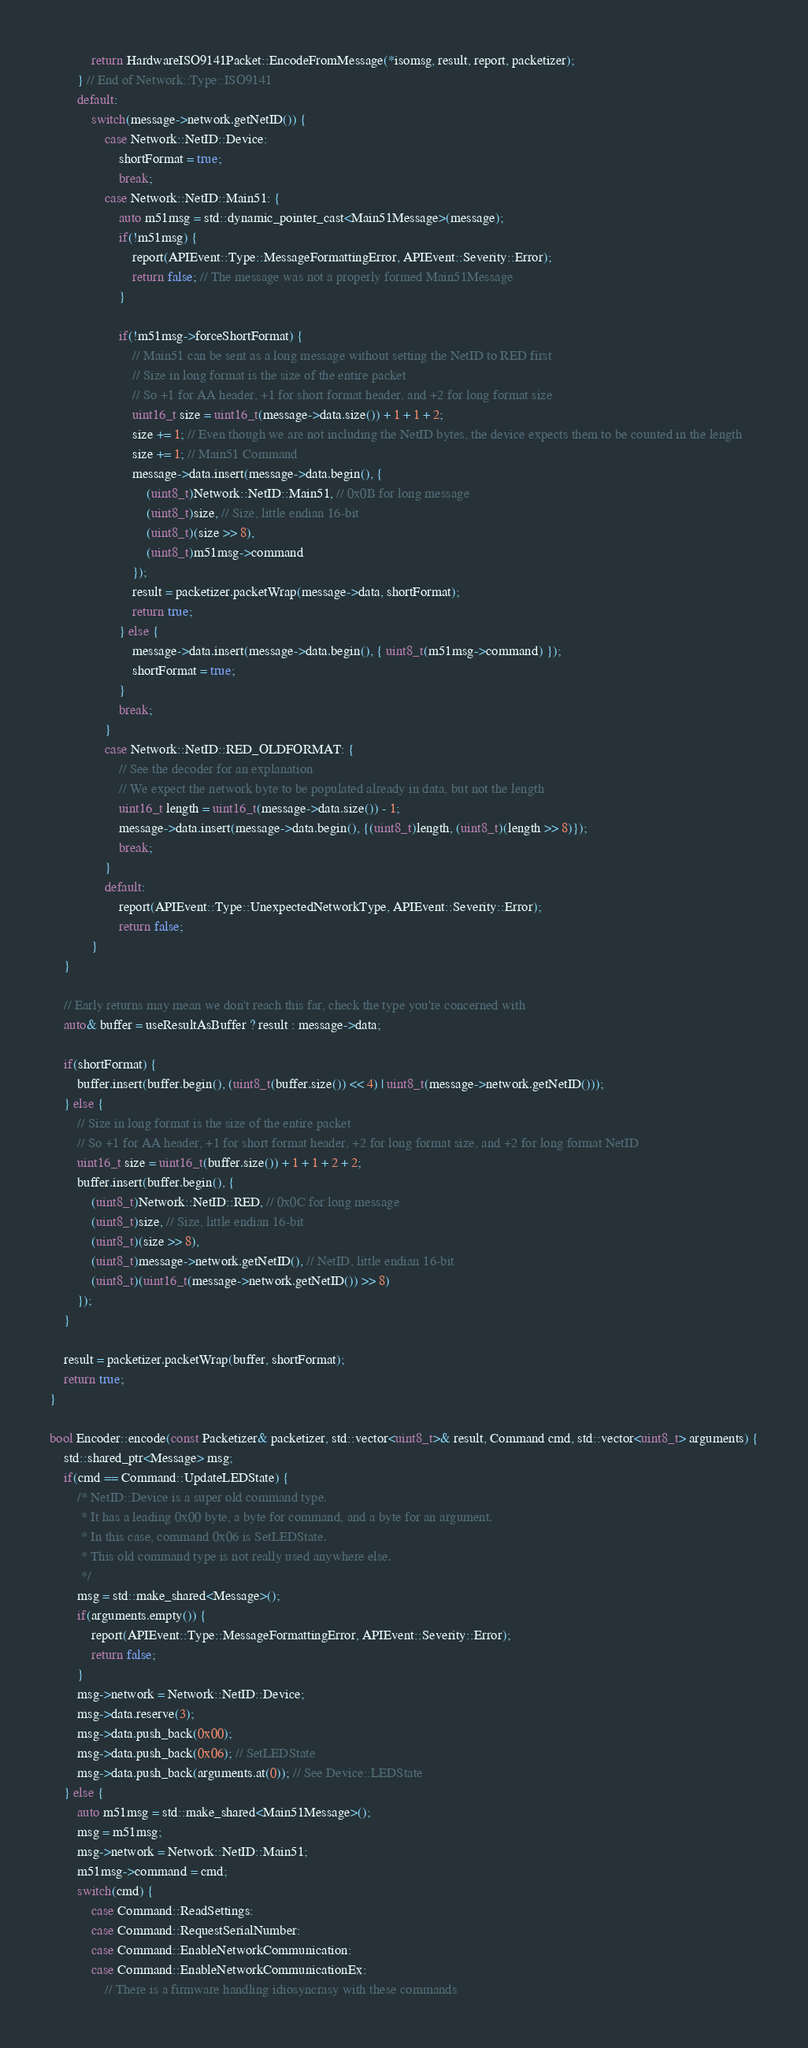<code> <loc_0><loc_0><loc_500><loc_500><_C++_>			return HardwareISO9141Packet::EncodeFromMessage(*isomsg, result, report, packetizer);
		} // End of Network::Type::ISO9141
		default:
			switch(message->network.getNetID()) {
				case Network::NetID::Device:
					shortFormat = true;
					break;
				case Network::NetID::Main51: {
					auto m51msg = std::dynamic_pointer_cast<Main51Message>(message);
					if(!m51msg) {
						report(APIEvent::Type::MessageFormattingError, APIEvent::Severity::Error);
						return false; // The message was not a properly formed Main51Message
					}

					if(!m51msg->forceShortFormat) {
						// Main51 can be sent as a long message without setting the NetID to RED first
						// Size in long format is the size of the entire packet
						// So +1 for AA header, +1 for short format header, and +2 for long format size
						uint16_t size = uint16_t(message->data.size()) + 1 + 1 + 2;
						size += 1; // Even though we are not including the NetID bytes, the device expects them to be counted in the length
						size += 1; // Main51 Command
						message->data.insert(message->data.begin(), {
							(uint8_t)Network::NetID::Main51, // 0x0B for long message
							(uint8_t)size, // Size, little endian 16-bit
							(uint8_t)(size >> 8),
							(uint8_t)m51msg->command
						});
						result = packetizer.packetWrap(message->data, shortFormat);
						return true;
					} else {
						message->data.insert(message->data.begin(), { uint8_t(m51msg->command) });
						shortFormat = true;
					}
					break;
				}
				case Network::NetID::RED_OLDFORMAT: {
					// See the decoder for an explanation
					// We expect the network byte to be populated already in data, but not the length
					uint16_t length = uint16_t(message->data.size()) - 1;
					message->data.insert(message->data.begin(), {(uint8_t)length, (uint8_t)(length >> 8)});
					break;
				}
				default:
					report(APIEvent::Type::UnexpectedNetworkType, APIEvent::Severity::Error);
					return false;
			}
	}

	// Early returns may mean we don't reach this far, check the type you're concerned with
	auto& buffer = useResultAsBuffer ? result : message->data;

	if(shortFormat) {
		buffer.insert(buffer.begin(), (uint8_t(buffer.size()) << 4) | uint8_t(message->network.getNetID()));
	} else {
		// Size in long format is the size of the entire packet
		// So +1 for AA header, +1 for short format header, +2 for long format size, and +2 for long format NetID
		uint16_t size = uint16_t(buffer.size()) + 1 + 1 + 2 + 2;
		buffer.insert(buffer.begin(), {
			(uint8_t)Network::NetID::RED, // 0x0C for long message
			(uint8_t)size, // Size, little endian 16-bit
			(uint8_t)(size >> 8),
			(uint8_t)message->network.getNetID(), // NetID, little endian 16-bit
			(uint8_t)(uint16_t(message->network.getNetID()) >> 8)
		});
	}

	result = packetizer.packetWrap(buffer, shortFormat);
	return true;
}

bool Encoder::encode(const Packetizer& packetizer, std::vector<uint8_t>& result, Command cmd, std::vector<uint8_t> arguments) {
	std::shared_ptr<Message> msg;
	if(cmd == Command::UpdateLEDState) {
		/* NetID::Device is a super old command type.
		 * It has a leading 0x00 byte, a byte for command, and a byte for an argument.
		 * In this case, command 0x06 is SetLEDState.
		 * This old command type is not really used anywhere else.
		 */
		msg = std::make_shared<Message>();
		if(arguments.empty()) {
			report(APIEvent::Type::MessageFormattingError, APIEvent::Severity::Error);
			return false;
		}
		msg->network = Network::NetID::Device;
		msg->data.reserve(3);
		msg->data.push_back(0x00);
		msg->data.push_back(0x06); // SetLEDState
		msg->data.push_back(arguments.at(0)); // See Device::LEDState
	} else {
		auto m51msg = std::make_shared<Main51Message>();
		msg = m51msg;
		msg->network = Network::NetID::Main51;
		m51msg->command = cmd;
		switch(cmd) {
			case Command::ReadSettings:
			case Command::RequestSerialNumber:
			case Command::EnableNetworkCommunication:
			case Command::EnableNetworkCommunicationEx:
				// There is a firmware handling idiosyncrasy with these commands</code> 